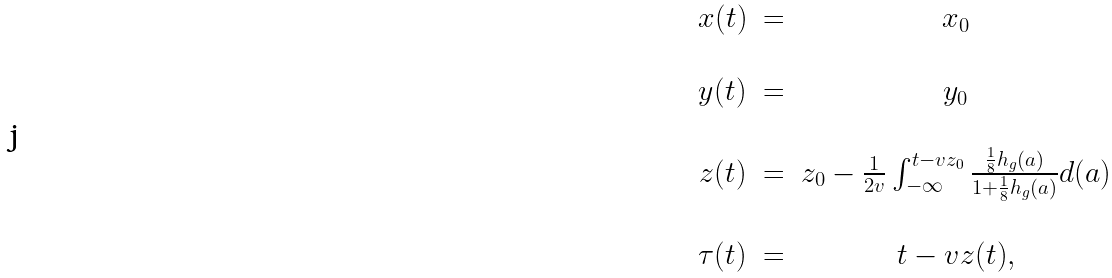Convert formula to latex. <formula><loc_0><loc_0><loc_500><loc_500>\begin{array} { c c c } x ( t ) & = & x _ { 0 } \\ \\ y ( t ) & = & y _ { 0 } \\ \\ z ( t ) & = & z _ { 0 } - \frac { 1 } { 2 v } \int _ { - \infty } ^ { t - v z _ { 0 } } \frac { \frac { 1 } { 8 } h _ { g } ( a ) } { 1 + \frac { 1 } { 8 } h _ { g } ( a ) } d ( a ) \\ \\ \tau ( t ) & = & t - v z ( t ) , \end{array}</formula> 